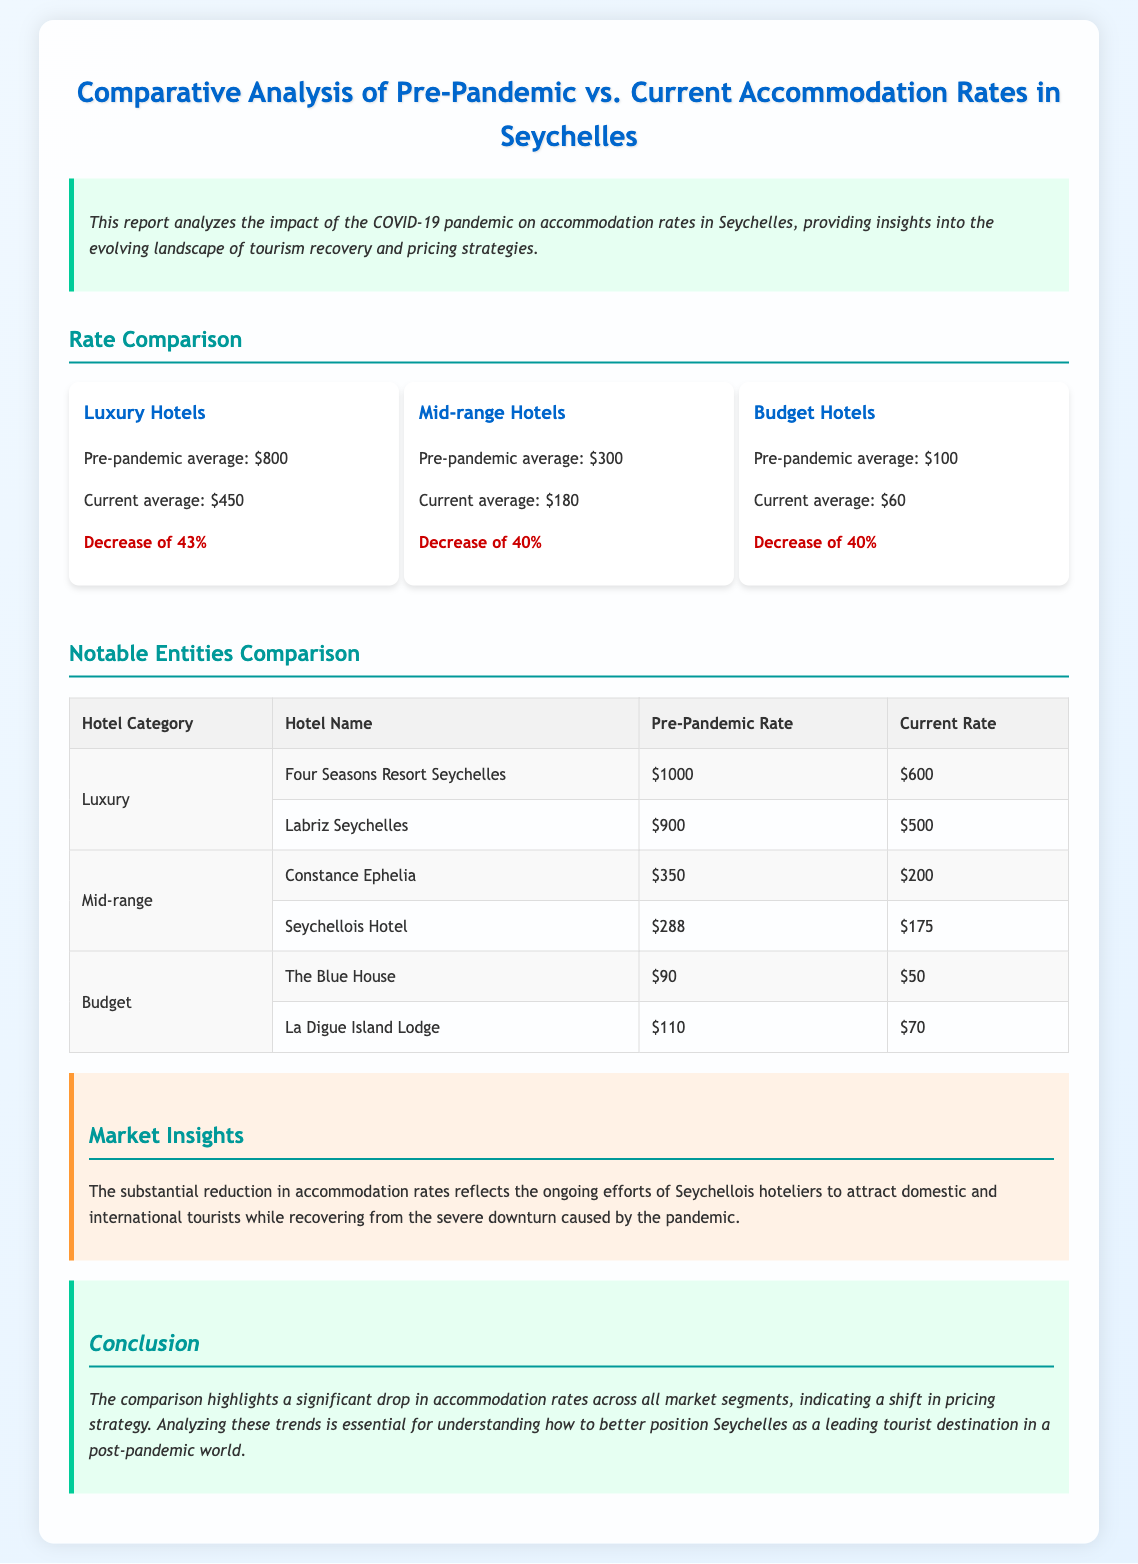What was the pre-pandemic average rate for luxury hotels? The document states that the pre-pandemic average rate for luxury hotels was $800.
Answer: $800 What is the current average rate for budget hotels? According to the report, the current average for budget hotels is $60.
Answer: $60 By what percentage did the rates for mid-range hotels decrease? The document mentions a decrease of 40% in the rates for mid-range hotels.
Answer: 40% What are the names of the two luxury hotels listed in the document? The two luxury hotels mentioned are Four Seasons Resort Seychelles and Labriz Seychelles.
Answer: Four Seasons Resort Seychelles, Labriz Seychelles Which budget hotel has the higher current rate? The document lists La Digue Island Lodge as having the higher current rate of $70 compared to The Blue House's $50.
Answer: La Digue Island Lodge What is the main reason for the reduction in accommodation rates? The report highlights the need to attract tourists and recover from pandemic impacts as the reason for the rate reduction.
Answer: To attract tourists and recover from pandemic impacts What does the market insights section suggest about the hotel industry in Seychelles? The section indicates that Seychellois hoteliers are actively working to rebound by reducing rates.
Answer: Actively working to rebound by reducing rates What is the average pre-pandemic rate for mid-range hotels? The report states that the average pre-pandemic rate for mid-range hotels was $300.
Answer: $300 